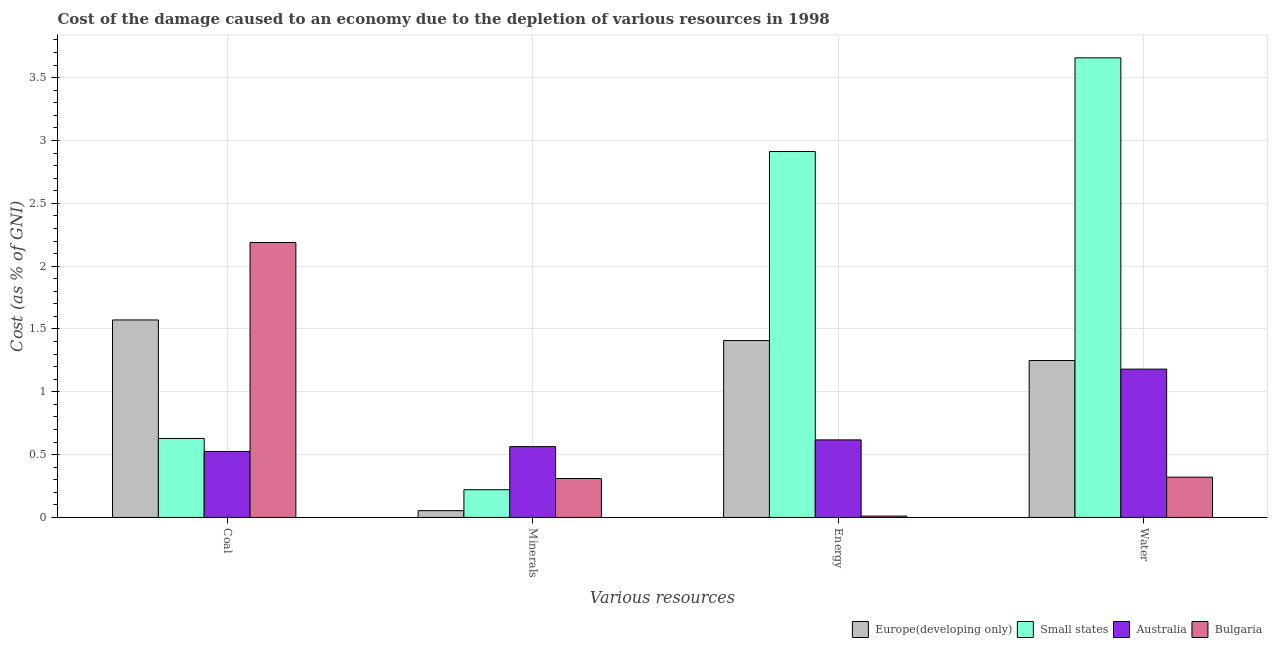How many groups of bars are there?
Ensure brevity in your answer.  4. Are the number of bars per tick equal to the number of legend labels?
Your answer should be compact. Yes. Are the number of bars on each tick of the X-axis equal?
Offer a terse response. Yes. What is the label of the 4th group of bars from the left?
Your response must be concise. Water. What is the cost of damage due to depletion of water in Small states?
Your answer should be very brief. 3.66. Across all countries, what is the maximum cost of damage due to depletion of energy?
Your response must be concise. 2.91. Across all countries, what is the minimum cost of damage due to depletion of coal?
Provide a short and direct response. 0.53. What is the total cost of damage due to depletion of minerals in the graph?
Provide a succinct answer. 1.15. What is the difference between the cost of damage due to depletion of minerals in Europe(developing only) and that in Australia?
Your answer should be very brief. -0.51. What is the difference between the cost of damage due to depletion of energy in Australia and the cost of damage due to depletion of minerals in Europe(developing only)?
Offer a very short reply. 0.56. What is the average cost of damage due to depletion of water per country?
Your response must be concise. 1.6. What is the difference between the cost of damage due to depletion of water and cost of damage due to depletion of coal in Australia?
Offer a terse response. 0.66. In how many countries, is the cost of damage due to depletion of water greater than 0.7 %?
Your answer should be very brief. 3. What is the ratio of the cost of damage due to depletion of coal in Europe(developing only) to that in Bulgaria?
Your response must be concise. 0.72. Is the cost of damage due to depletion of coal in Australia less than that in Europe(developing only)?
Offer a very short reply. Yes. What is the difference between the highest and the second highest cost of damage due to depletion of energy?
Offer a very short reply. 1.5. What is the difference between the highest and the lowest cost of damage due to depletion of minerals?
Your answer should be very brief. 0.51. In how many countries, is the cost of damage due to depletion of coal greater than the average cost of damage due to depletion of coal taken over all countries?
Make the answer very short. 2. Is it the case that in every country, the sum of the cost of damage due to depletion of energy and cost of damage due to depletion of coal is greater than the sum of cost of damage due to depletion of minerals and cost of damage due to depletion of water?
Ensure brevity in your answer.  No. What does the 3rd bar from the left in Coal represents?
Your answer should be very brief. Australia. What does the 3rd bar from the right in Coal represents?
Ensure brevity in your answer.  Small states. Is it the case that in every country, the sum of the cost of damage due to depletion of coal and cost of damage due to depletion of minerals is greater than the cost of damage due to depletion of energy?
Offer a terse response. No. How many bars are there?
Provide a succinct answer. 16. Are all the bars in the graph horizontal?
Provide a short and direct response. No. How many countries are there in the graph?
Keep it short and to the point. 4. Are the values on the major ticks of Y-axis written in scientific E-notation?
Offer a terse response. No. Does the graph contain grids?
Offer a very short reply. Yes. How are the legend labels stacked?
Give a very brief answer. Horizontal. What is the title of the graph?
Make the answer very short. Cost of the damage caused to an economy due to the depletion of various resources in 1998 . Does "Russian Federation" appear as one of the legend labels in the graph?
Your answer should be very brief. No. What is the label or title of the X-axis?
Offer a very short reply. Various resources. What is the label or title of the Y-axis?
Your answer should be compact. Cost (as % of GNI). What is the Cost (as % of GNI) of Europe(developing only) in Coal?
Your response must be concise. 1.57. What is the Cost (as % of GNI) in Small states in Coal?
Your answer should be very brief. 0.63. What is the Cost (as % of GNI) of Australia in Coal?
Offer a very short reply. 0.53. What is the Cost (as % of GNI) of Bulgaria in Coal?
Provide a succinct answer. 2.19. What is the Cost (as % of GNI) in Europe(developing only) in Minerals?
Keep it short and to the point. 0.05. What is the Cost (as % of GNI) of Small states in Minerals?
Give a very brief answer. 0.22. What is the Cost (as % of GNI) in Australia in Minerals?
Provide a short and direct response. 0.56. What is the Cost (as % of GNI) in Bulgaria in Minerals?
Keep it short and to the point. 0.31. What is the Cost (as % of GNI) of Europe(developing only) in Energy?
Provide a succinct answer. 1.41. What is the Cost (as % of GNI) in Small states in Energy?
Offer a very short reply. 2.91. What is the Cost (as % of GNI) in Australia in Energy?
Provide a succinct answer. 0.62. What is the Cost (as % of GNI) of Bulgaria in Energy?
Provide a succinct answer. 0.01. What is the Cost (as % of GNI) of Europe(developing only) in Water?
Offer a terse response. 1.25. What is the Cost (as % of GNI) in Small states in Water?
Offer a terse response. 3.66. What is the Cost (as % of GNI) in Australia in Water?
Your answer should be compact. 1.18. What is the Cost (as % of GNI) of Bulgaria in Water?
Keep it short and to the point. 0.32. Across all Various resources, what is the maximum Cost (as % of GNI) in Europe(developing only)?
Ensure brevity in your answer.  1.57. Across all Various resources, what is the maximum Cost (as % of GNI) of Small states?
Offer a very short reply. 3.66. Across all Various resources, what is the maximum Cost (as % of GNI) of Australia?
Keep it short and to the point. 1.18. Across all Various resources, what is the maximum Cost (as % of GNI) of Bulgaria?
Ensure brevity in your answer.  2.19. Across all Various resources, what is the minimum Cost (as % of GNI) in Europe(developing only)?
Keep it short and to the point. 0.05. Across all Various resources, what is the minimum Cost (as % of GNI) in Small states?
Give a very brief answer. 0.22. Across all Various resources, what is the minimum Cost (as % of GNI) of Australia?
Make the answer very short. 0.53. Across all Various resources, what is the minimum Cost (as % of GNI) in Bulgaria?
Provide a short and direct response. 0.01. What is the total Cost (as % of GNI) of Europe(developing only) in the graph?
Offer a very short reply. 4.28. What is the total Cost (as % of GNI) in Small states in the graph?
Your answer should be very brief. 7.42. What is the total Cost (as % of GNI) of Australia in the graph?
Your answer should be very brief. 2.89. What is the total Cost (as % of GNI) in Bulgaria in the graph?
Provide a succinct answer. 2.83. What is the difference between the Cost (as % of GNI) of Europe(developing only) in Coal and that in Minerals?
Give a very brief answer. 1.52. What is the difference between the Cost (as % of GNI) in Small states in Coal and that in Minerals?
Provide a succinct answer. 0.41. What is the difference between the Cost (as % of GNI) in Australia in Coal and that in Minerals?
Offer a terse response. -0.04. What is the difference between the Cost (as % of GNI) of Bulgaria in Coal and that in Minerals?
Your answer should be very brief. 1.88. What is the difference between the Cost (as % of GNI) in Europe(developing only) in Coal and that in Energy?
Your answer should be very brief. 0.16. What is the difference between the Cost (as % of GNI) in Small states in Coal and that in Energy?
Ensure brevity in your answer.  -2.28. What is the difference between the Cost (as % of GNI) in Australia in Coal and that in Energy?
Your answer should be very brief. -0.09. What is the difference between the Cost (as % of GNI) of Bulgaria in Coal and that in Energy?
Your answer should be very brief. 2.18. What is the difference between the Cost (as % of GNI) in Europe(developing only) in Coal and that in Water?
Make the answer very short. 0.32. What is the difference between the Cost (as % of GNI) of Small states in Coal and that in Water?
Provide a succinct answer. -3.03. What is the difference between the Cost (as % of GNI) in Australia in Coal and that in Water?
Offer a very short reply. -0.66. What is the difference between the Cost (as % of GNI) of Bulgaria in Coal and that in Water?
Offer a very short reply. 1.87. What is the difference between the Cost (as % of GNI) in Europe(developing only) in Minerals and that in Energy?
Your response must be concise. -1.35. What is the difference between the Cost (as % of GNI) in Small states in Minerals and that in Energy?
Provide a short and direct response. -2.69. What is the difference between the Cost (as % of GNI) of Australia in Minerals and that in Energy?
Your answer should be very brief. -0.05. What is the difference between the Cost (as % of GNI) of Bulgaria in Minerals and that in Energy?
Provide a succinct answer. 0.3. What is the difference between the Cost (as % of GNI) of Europe(developing only) in Minerals and that in Water?
Keep it short and to the point. -1.19. What is the difference between the Cost (as % of GNI) in Small states in Minerals and that in Water?
Provide a succinct answer. -3.44. What is the difference between the Cost (as % of GNI) in Australia in Minerals and that in Water?
Make the answer very short. -0.62. What is the difference between the Cost (as % of GNI) in Bulgaria in Minerals and that in Water?
Provide a short and direct response. -0.01. What is the difference between the Cost (as % of GNI) in Europe(developing only) in Energy and that in Water?
Offer a very short reply. 0.16. What is the difference between the Cost (as % of GNI) of Small states in Energy and that in Water?
Offer a terse response. -0.75. What is the difference between the Cost (as % of GNI) of Australia in Energy and that in Water?
Provide a succinct answer. -0.56. What is the difference between the Cost (as % of GNI) of Bulgaria in Energy and that in Water?
Provide a short and direct response. -0.31. What is the difference between the Cost (as % of GNI) of Europe(developing only) in Coal and the Cost (as % of GNI) of Small states in Minerals?
Keep it short and to the point. 1.35. What is the difference between the Cost (as % of GNI) of Europe(developing only) in Coal and the Cost (as % of GNI) of Australia in Minerals?
Your answer should be compact. 1.01. What is the difference between the Cost (as % of GNI) of Europe(developing only) in Coal and the Cost (as % of GNI) of Bulgaria in Minerals?
Make the answer very short. 1.26. What is the difference between the Cost (as % of GNI) in Small states in Coal and the Cost (as % of GNI) in Australia in Minerals?
Provide a succinct answer. 0.07. What is the difference between the Cost (as % of GNI) in Small states in Coal and the Cost (as % of GNI) in Bulgaria in Minerals?
Keep it short and to the point. 0.32. What is the difference between the Cost (as % of GNI) of Australia in Coal and the Cost (as % of GNI) of Bulgaria in Minerals?
Offer a terse response. 0.22. What is the difference between the Cost (as % of GNI) in Europe(developing only) in Coal and the Cost (as % of GNI) in Small states in Energy?
Offer a very short reply. -1.34. What is the difference between the Cost (as % of GNI) of Europe(developing only) in Coal and the Cost (as % of GNI) of Australia in Energy?
Provide a short and direct response. 0.95. What is the difference between the Cost (as % of GNI) in Europe(developing only) in Coal and the Cost (as % of GNI) in Bulgaria in Energy?
Provide a short and direct response. 1.56. What is the difference between the Cost (as % of GNI) of Small states in Coal and the Cost (as % of GNI) of Australia in Energy?
Your response must be concise. 0.01. What is the difference between the Cost (as % of GNI) in Small states in Coal and the Cost (as % of GNI) in Bulgaria in Energy?
Your answer should be compact. 0.62. What is the difference between the Cost (as % of GNI) in Australia in Coal and the Cost (as % of GNI) in Bulgaria in Energy?
Offer a very short reply. 0.51. What is the difference between the Cost (as % of GNI) in Europe(developing only) in Coal and the Cost (as % of GNI) in Small states in Water?
Your answer should be very brief. -2.09. What is the difference between the Cost (as % of GNI) of Europe(developing only) in Coal and the Cost (as % of GNI) of Australia in Water?
Offer a very short reply. 0.39. What is the difference between the Cost (as % of GNI) in Europe(developing only) in Coal and the Cost (as % of GNI) in Bulgaria in Water?
Your answer should be compact. 1.25. What is the difference between the Cost (as % of GNI) in Small states in Coal and the Cost (as % of GNI) in Australia in Water?
Give a very brief answer. -0.55. What is the difference between the Cost (as % of GNI) in Small states in Coal and the Cost (as % of GNI) in Bulgaria in Water?
Provide a short and direct response. 0.31. What is the difference between the Cost (as % of GNI) in Australia in Coal and the Cost (as % of GNI) in Bulgaria in Water?
Provide a short and direct response. 0.2. What is the difference between the Cost (as % of GNI) of Europe(developing only) in Minerals and the Cost (as % of GNI) of Small states in Energy?
Give a very brief answer. -2.86. What is the difference between the Cost (as % of GNI) in Europe(developing only) in Minerals and the Cost (as % of GNI) in Australia in Energy?
Your response must be concise. -0.56. What is the difference between the Cost (as % of GNI) of Europe(developing only) in Minerals and the Cost (as % of GNI) of Bulgaria in Energy?
Make the answer very short. 0.04. What is the difference between the Cost (as % of GNI) in Small states in Minerals and the Cost (as % of GNI) in Australia in Energy?
Your response must be concise. -0.4. What is the difference between the Cost (as % of GNI) of Small states in Minerals and the Cost (as % of GNI) of Bulgaria in Energy?
Keep it short and to the point. 0.21. What is the difference between the Cost (as % of GNI) of Australia in Minerals and the Cost (as % of GNI) of Bulgaria in Energy?
Your answer should be compact. 0.55. What is the difference between the Cost (as % of GNI) in Europe(developing only) in Minerals and the Cost (as % of GNI) in Small states in Water?
Provide a short and direct response. -3.6. What is the difference between the Cost (as % of GNI) of Europe(developing only) in Minerals and the Cost (as % of GNI) of Australia in Water?
Ensure brevity in your answer.  -1.13. What is the difference between the Cost (as % of GNI) in Europe(developing only) in Minerals and the Cost (as % of GNI) in Bulgaria in Water?
Provide a succinct answer. -0.27. What is the difference between the Cost (as % of GNI) of Small states in Minerals and the Cost (as % of GNI) of Australia in Water?
Offer a terse response. -0.96. What is the difference between the Cost (as % of GNI) in Small states in Minerals and the Cost (as % of GNI) in Bulgaria in Water?
Keep it short and to the point. -0.1. What is the difference between the Cost (as % of GNI) of Australia in Minerals and the Cost (as % of GNI) of Bulgaria in Water?
Your response must be concise. 0.24. What is the difference between the Cost (as % of GNI) in Europe(developing only) in Energy and the Cost (as % of GNI) in Small states in Water?
Offer a very short reply. -2.25. What is the difference between the Cost (as % of GNI) in Europe(developing only) in Energy and the Cost (as % of GNI) in Australia in Water?
Ensure brevity in your answer.  0.23. What is the difference between the Cost (as % of GNI) in Europe(developing only) in Energy and the Cost (as % of GNI) in Bulgaria in Water?
Offer a very short reply. 1.09. What is the difference between the Cost (as % of GNI) of Small states in Energy and the Cost (as % of GNI) of Australia in Water?
Give a very brief answer. 1.73. What is the difference between the Cost (as % of GNI) in Small states in Energy and the Cost (as % of GNI) in Bulgaria in Water?
Provide a short and direct response. 2.59. What is the difference between the Cost (as % of GNI) in Australia in Energy and the Cost (as % of GNI) in Bulgaria in Water?
Your answer should be very brief. 0.3. What is the average Cost (as % of GNI) in Europe(developing only) per Various resources?
Ensure brevity in your answer.  1.07. What is the average Cost (as % of GNI) of Small states per Various resources?
Make the answer very short. 1.85. What is the average Cost (as % of GNI) of Australia per Various resources?
Offer a very short reply. 0.72. What is the average Cost (as % of GNI) in Bulgaria per Various resources?
Your answer should be very brief. 0.71. What is the difference between the Cost (as % of GNI) in Europe(developing only) and Cost (as % of GNI) in Small states in Coal?
Keep it short and to the point. 0.94. What is the difference between the Cost (as % of GNI) in Europe(developing only) and Cost (as % of GNI) in Australia in Coal?
Your answer should be compact. 1.05. What is the difference between the Cost (as % of GNI) of Europe(developing only) and Cost (as % of GNI) of Bulgaria in Coal?
Your answer should be very brief. -0.62. What is the difference between the Cost (as % of GNI) of Small states and Cost (as % of GNI) of Australia in Coal?
Provide a short and direct response. 0.1. What is the difference between the Cost (as % of GNI) in Small states and Cost (as % of GNI) in Bulgaria in Coal?
Your answer should be compact. -1.56. What is the difference between the Cost (as % of GNI) in Australia and Cost (as % of GNI) in Bulgaria in Coal?
Offer a very short reply. -1.66. What is the difference between the Cost (as % of GNI) of Europe(developing only) and Cost (as % of GNI) of Australia in Minerals?
Give a very brief answer. -0.51. What is the difference between the Cost (as % of GNI) of Europe(developing only) and Cost (as % of GNI) of Bulgaria in Minerals?
Offer a terse response. -0.26. What is the difference between the Cost (as % of GNI) in Small states and Cost (as % of GNI) in Australia in Minerals?
Make the answer very short. -0.34. What is the difference between the Cost (as % of GNI) of Small states and Cost (as % of GNI) of Bulgaria in Minerals?
Your answer should be compact. -0.09. What is the difference between the Cost (as % of GNI) of Australia and Cost (as % of GNI) of Bulgaria in Minerals?
Offer a very short reply. 0.25. What is the difference between the Cost (as % of GNI) in Europe(developing only) and Cost (as % of GNI) in Small states in Energy?
Ensure brevity in your answer.  -1.5. What is the difference between the Cost (as % of GNI) in Europe(developing only) and Cost (as % of GNI) in Australia in Energy?
Ensure brevity in your answer.  0.79. What is the difference between the Cost (as % of GNI) of Europe(developing only) and Cost (as % of GNI) of Bulgaria in Energy?
Your answer should be very brief. 1.4. What is the difference between the Cost (as % of GNI) of Small states and Cost (as % of GNI) of Australia in Energy?
Your answer should be compact. 2.3. What is the difference between the Cost (as % of GNI) of Small states and Cost (as % of GNI) of Bulgaria in Energy?
Give a very brief answer. 2.9. What is the difference between the Cost (as % of GNI) in Australia and Cost (as % of GNI) in Bulgaria in Energy?
Offer a terse response. 0.61. What is the difference between the Cost (as % of GNI) of Europe(developing only) and Cost (as % of GNI) of Small states in Water?
Your response must be concise. -2.41. What is the difference between the Cost (as % of GNI) in Europe(developing only) and Cost (as % of GNI) in Australia in Water?
Offer a terse response. 0.07. What is the difference between the Cost (as % of GNI) of Europe(developing only) and Cost (as % of GNI) of Bulgaria in Water?
Offer a very short reply. 0.93. What is the difference between the Cost (as % of GNI) in Small states and Cost (as % of GNI) in Australia in Water?
Provide a short and direct response. 2.48. What is the difference between the Cost (as % of GNI) in Small states and Cost (as % of GNI) in Bulgaria in Water?
Provide a short and direct response. 3.34. What is the difference between the Cost (as % of GNI) in Australia and Cost (as % of GNI) in Bulgaria in Water?
Offer a very short reply. 0.86. What is the ratio of the Cost (as % of GNI) of Europe(developing only) in Coal to that in Minerals?
Your response must be concise. 29.18. What is the ratio of the Cost (as % of GNI) of Small states in Coal to that in Minerals?
Make the answer very short. 2.85. What is the ratio of the Cost (as % of GNI) in Australia in Coal to that in Minerals?
Provide a short and direct response. 0.93. What is the ratio of the Cost (as % of GNI) of Bulgaria in Coal to that in Minerals?
Offer a terse response. 7.06. What is the ratio of the Cost (as % of GNI) of Europe(developing only) in Coal to that in Energy?
Provide a succinct answer. 1.12. What is the ratio of the Cost (as % of GNI) of Small states in Coal to that in Energy?
Give a very brief answer. 0.22. What is the ratio of the Cost (as % of GNI) of Australia in Coal to that in Energy?
Ensure brevity in your answer.  0.85. What is the ratio of the Cost (as % of GNI) in Bulgaria in Coal to that in Energy?
Ensure brevity in your answer.  204.94. What is the ratio of the Cost (as % of GNI) in Europe(developing only) in Coal to that in Water?
Give a very brief answer. 1.26. What is the ratio of the Cost (as % of GNI) in Small states in Coal to that in Water?
Offer a terse response. 0.17. What is the ratio of the Cost (as % of GNI) in Australia in Coal to that in Water?
Provide a short and direct response. 0.44. What is the ratio of the Cost (as % of GNI) in Bulgaria in Coal to that in Water?
Your answer should be compact. 6.83. What is the ratio of the Cost (as % of GNI) of Europe(developing only) in Minerals to that in Energy?
Give a very brief answer. 0.04. What is the ratio of the Cost (as % of GNI) in Small states in Minerals to that in Energy?
Your answer should be very brief. 0.08. What is the ratio of the Cost (as % of GNI) in Australia in Minerals to that in Energy?
Give a very brief answer. 0.91. What is the ratio of the Cost (as % of GNI) in Bulgaria in Minerals to that in Energy?
Offer a terse response. 29.01. What is the ratio of the Cost (as % of GNI) of Europe(developing only) in Minerals to that in Water?
Provide a succinct answer. 0.04. What is the ratio of the Cost (as % of GNI) in Small states in Minerals to that in Water?
Your answer should be compact. 0.06. What is the ratio of the Cost (as % of GNI) of Australia in Minerals to that in Water?
Offer a very short reply. 0.48. What is the ratio of the Cost (as % of GNI) of Bulgaria in Minerals to that in Water?
Provide a short and direct response. 0.97. What is the ratio of the Cost (as % of GNI) in Europe(developing only) in Energy to that in Water?
Offer a terse response. 1.13. What is the ratio of the Cost (as % of GNI) in Small states in Energy to that in Water?
Make the answer very short. 0.8. What is the ratio of the Cost (as % of GNI) in Australia in Energy to that in Water?
Your answer should be very brief. 0.52. What is the difference between the highest and the second highest Cost (as % of GNI) of Europe(developing only)?
Your response must be concise. 0.16. What is the difference between the highest and the second highest Cost (as % of GNI) of Small states?
Your answer should be very brief. 0.75. What is the difference between the highest and the second highest Cost (as % of GNI) of Australia?
Ensure brevity in your answer.  0.56. What is the difference between the highest and the second highest Cost (as % of GNI) in Bulgaria?
Your response must be concise. 1.87. What is the difference between the highest and the lowest Cost (as % of GNI) of Europe(developing only)?
Ensure brevity in your answer.  1.52. What is the difference between the highest and the lowest Cost (as % of GNI) in Small states?
Give a very brief answer. 3.44. What is the difference between the highest and the lowest Cost (as % of GNI) of Australia?
Make the answer very short. 0.66. What is the difference between the highest and the lowest Cost (as % of GNI) in Bulgaria?
Keep it short and to the point. 2.18. 